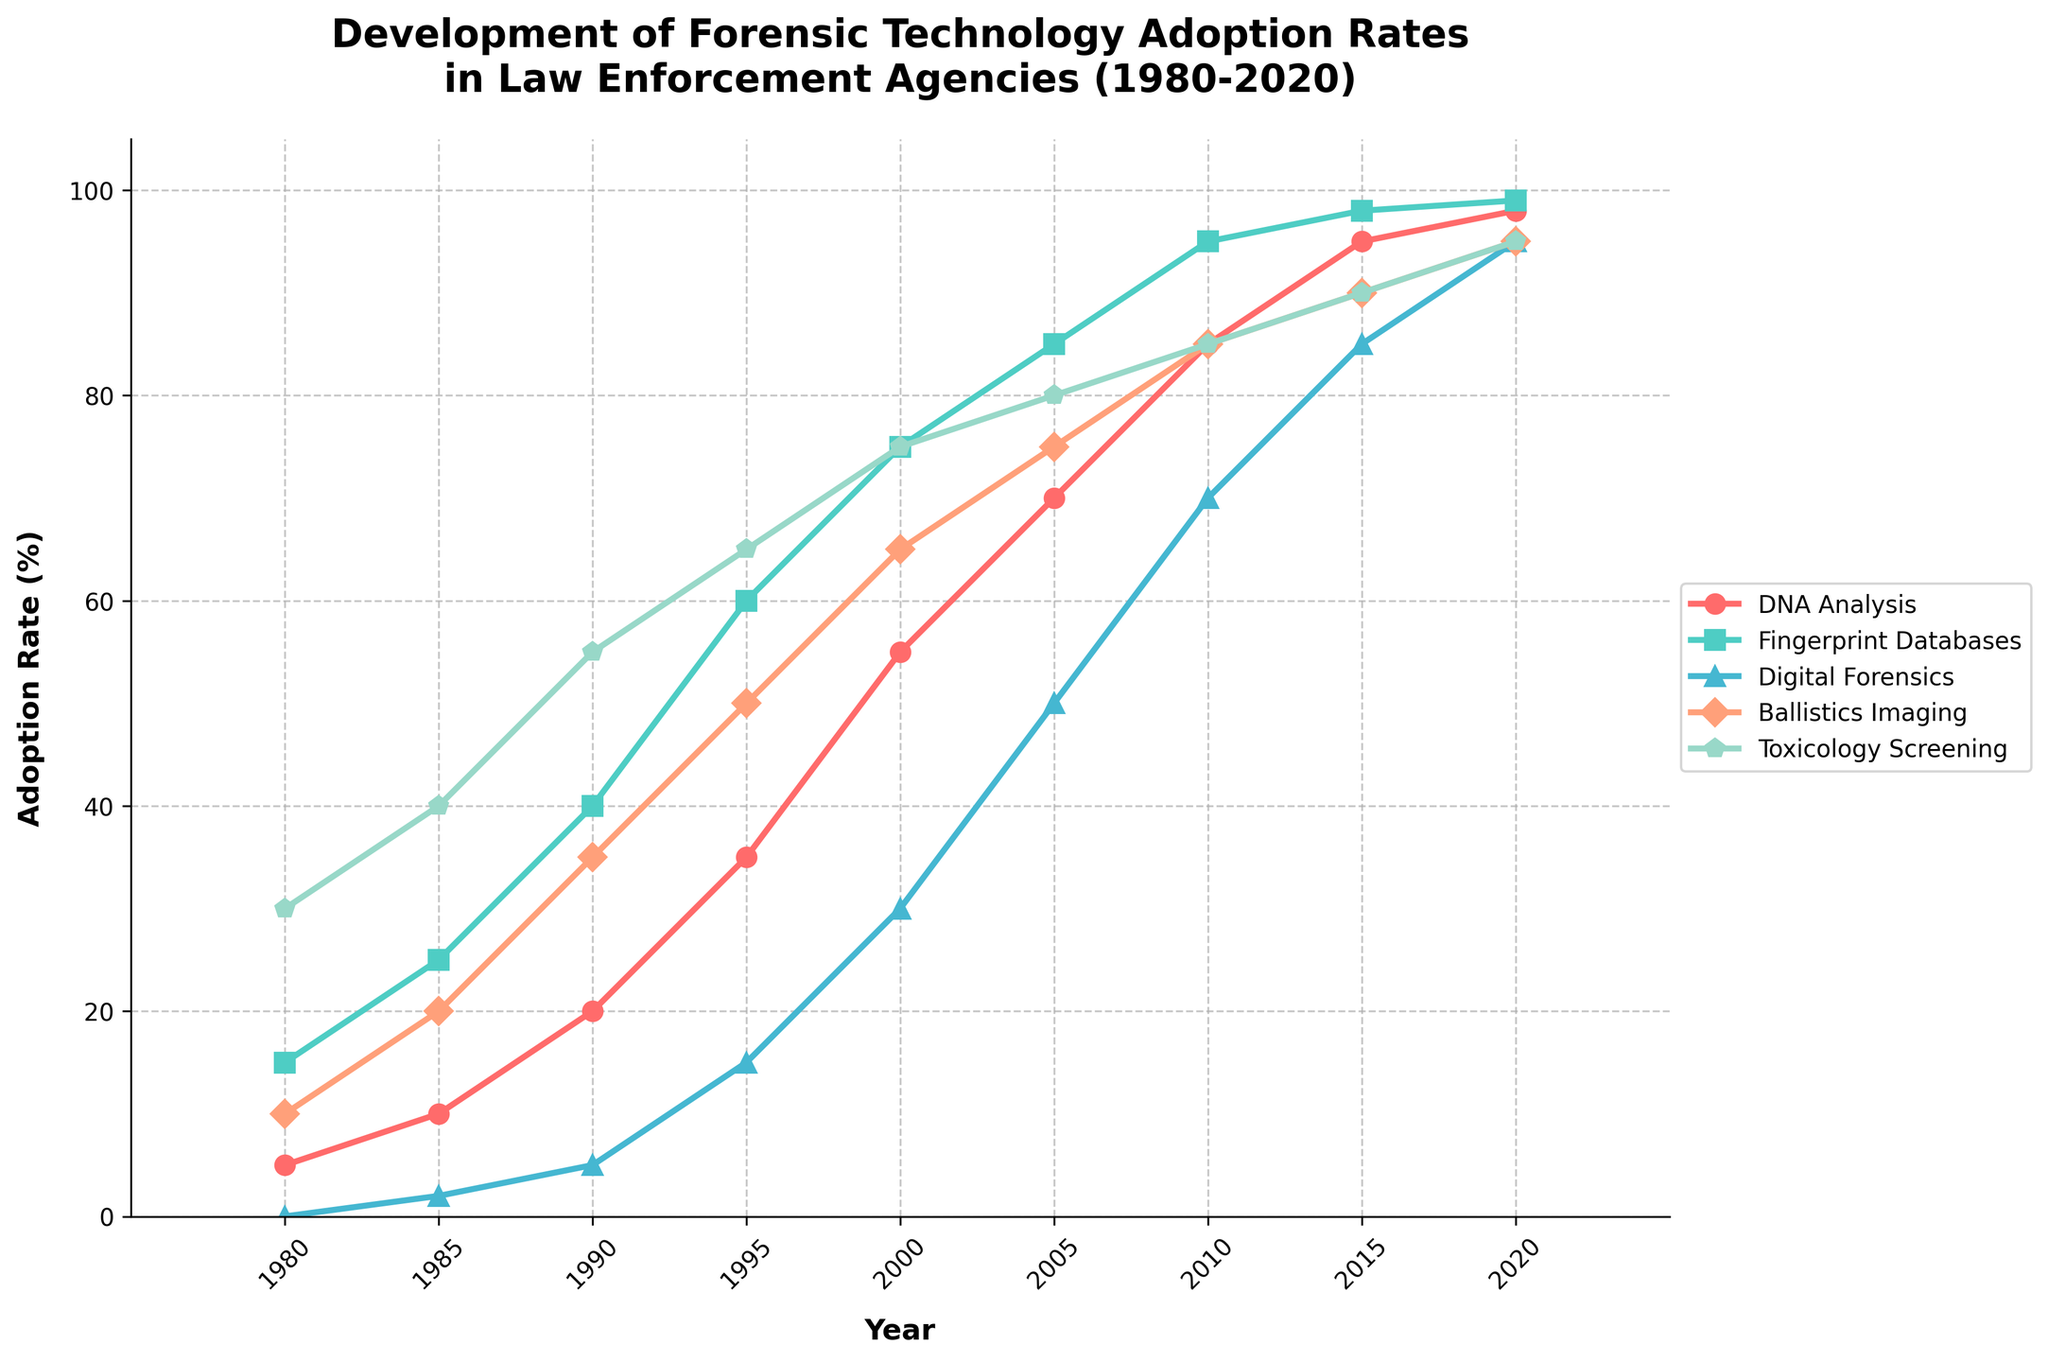What was the adoption rate of DNA Analysis in 1995? Locate the data point for DNA Analysis on the plot at the year 1995. The value should correspond to where the DNA Analysis line intersects the vertical line at 1995.
Answer: 35 Which forensic technology had the highest adoption rate in 1980? Compare the heights of the lines corresponding to each forensic technology at the year 1980. The technology with the tallest line segment at this year has the highest adoption rate.
Answer: Toxicology Screening Between 2000 and 2010, which forensic technology saw the greatest increase in adoption rate? Calculate the difference in adoption rates for each forensic technology between the years 2000 and 2010. The technology with the highest difference had the greatest increase.
Answer: Digital Forensics In what year did Fingerprint Databases adoption rate first reach 75%? Identify the data point where the Fingerprint Databases line first crosses the 75% adoption rate threshold. Look for the year label at this point on the x-axis.
Answer: 2000 Which technology showed a steeper increase in adoption rate between 1985 and 1995, Ballistics Imaging or DNA Analysis? Compare the slopes of the line segments representing Ballistics Imaging and DNA Analysis between 1985 and 1995. Steeper slopes indicate a steeper increase.
Answer: DNA Analysis What's the average adoption rate of Digital Forensics from 2000 to 2020? Sum the adoption rates of Digital Forensics for the years 2000, 2005, 2010, 2015, and 2020, then divide by the number of years (5). Calculation: (30 + 50 + 70 + 85 + 95) / 5.
Answer: 66 Which forensic technology had a higher adoption rate in 2010, Toxicology Screening or DNA Analysis? Compare the heights of the lines corresponding to Toxicology Screening and DNA Analysis at the year 2010. Determine which is taller.
Answer: DNA Analysis What is the difference in adoption rates between Fingerprint Databases and Ballistics Imaging in the year 2005? Find the values for Fingerprint Databases and Ballistics Imaging in 2005 and subtract Ballistics Imaging's rate from Fingerprint Databases' rate. Calculation: 85 - 75.
Answer: 10 How many years did it take for DNA Analysis to go from 5% to 95% adoption rate? Identify the years where DNA Analysis has 5% and 95% adoption rates. Subtract the year with 5% from the year with 95%. Calculation: 2015 - 1980.
Answer: 35 When did Digital Forensics adoption rate first surpass that of Fingerprint Databases? Compare the Digital Forensics and Fingerprint Databases lines. Identify the year where the Digital Forensics line first goes higher than the Fingerprint Databases line.
Answer: 2020 